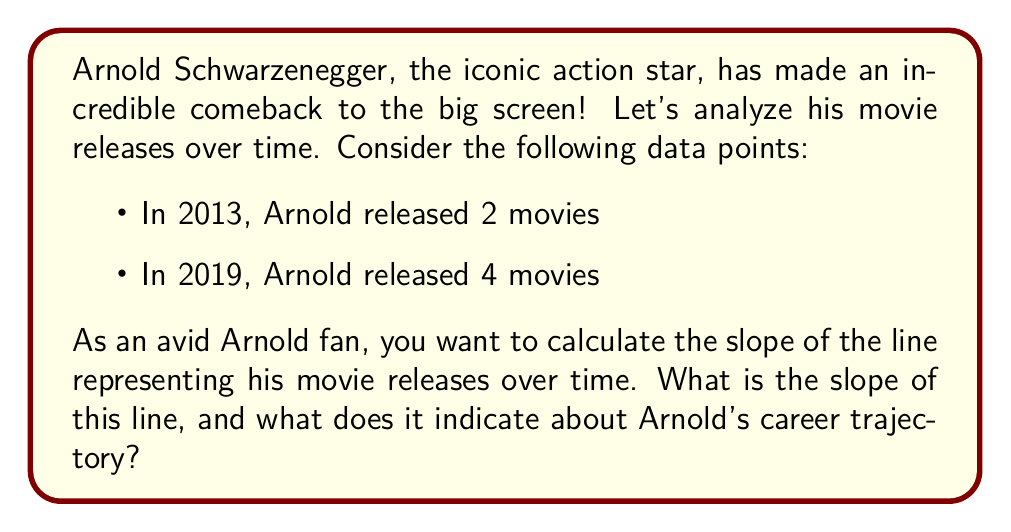Teach me how to tackle this problem. To find the slope of the line representing Arnold's movie releases over time, we'll use the slope formula:

$$ m = \frac{y_2 - y_1}{x_2 - x_1} $$

Where:
- $(x_1, y_1)$ is the first point (2013, 2)
- $(x_2, y_2)$ is the second point (2019, 4)

Let's plug these values into the formula:

$$ m = \frac{4 - 2}{2019 - 2013} = \frac{2}{6} = \frac{1}{3} $$

To simplify:
1. Subtract the y-coordinates: $4 - 2 = 2$
2. Subtract the x-coordinates: $2019 - 2013 = 6$
3. Divide the difference in y by the difference in x: $\frac{2}{6} = \frac{1}{3}$

The slope is positive, which indicates an upward trend in Arnold's movie releases over time. Specifically, it means that for each year that passes, Arnold is releasing an average of $\frac{1}{3}$ more movies.

This positive slope is great news for Arnold fans, as it suggests he's becoming more active in the film industry!
Answer: The slope of the line representing Arnold Schwarzenegger's movie releases over time is $\frac{1}{3}$, indicating an increasing trend in his movie output. 